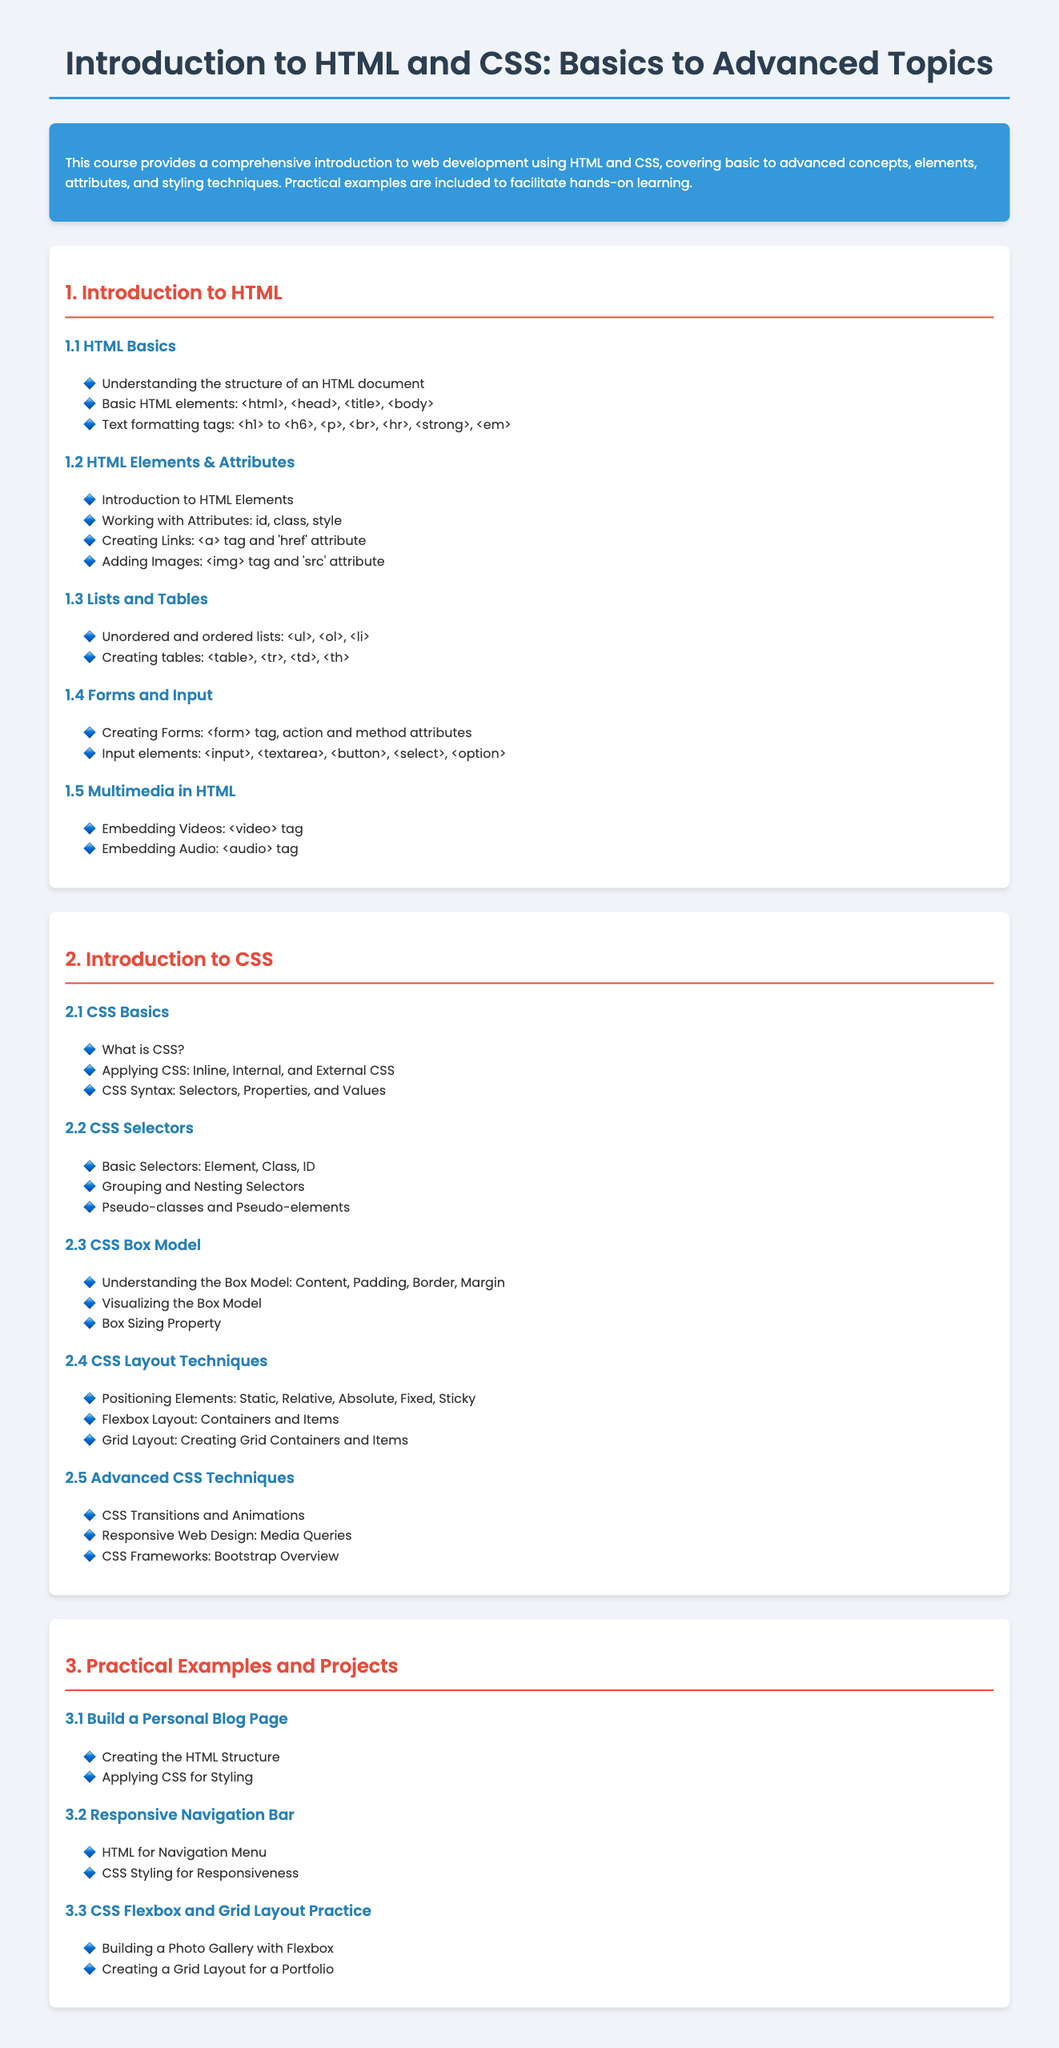what is the title of the syllabus? The title of the syllabus is found in the `<title>` tag of the document, which states the subject of the course.
Answer: Introduction to HTML and CSS: Basics to Advanced Topics what is the main focus of the course? The main focus is described in the introductory paragraph within the description section of the syllabus.
Answer: Comprehensive introduction to web development using HTML and CSS how many units are in the syllabus? The number of units can be counted from the headings in the syllabus.
Answer: 3 what are the main topics covered in Unit 2? The main topics can be derived from the headings listed in Unit 2 of the syllabus.
Answer: CSS Basics, CSS Selectors, CSS Box Model, CSS Layout Techniques, Advanced CSS Techniques which HTML elements are listed under HTML Basics? The specific elements are mentioned as part of the bullet points under the HTML Basics topic.
Answer: html, head, title, body what is included in the Practical Examples section? The specific projects are outlined as topics in the Practical Examples and Projects unit.
Answer: Build a Personal Blog Page, Responsive Navigation Bar, CSS Flexbox and Grid Layout Practice in what context is Bootstrap mentioned in the syllabus? Bootstrap is mentioned in the last topic of Unit 2, referring to a specific subject covered within CSS techniques.
Answer: CSS Frameworks: Bootstrap Overview how does the syllabus describe multimedia in HTML? The description is provided under the topic Multimedia in HTML in Unit 1, elaborating on what can be embedded.
Answer: Embedding Videos, Embedding Audio what types of input elements are mentioned in the Forms and Input topic? The types of input elements are listed in the Forms and Input section, detailing what can be included in HTML forms.
Answer: input, textarea, button, select, option what are the learning outcomes of the HTML Elements & Attributes section? The outcomes are inferred from the topics covered in that section, highlighting the key learning points.
Answer: Introduction to HTML Elements, Working with Attributes, Creating Links, Adding Images 